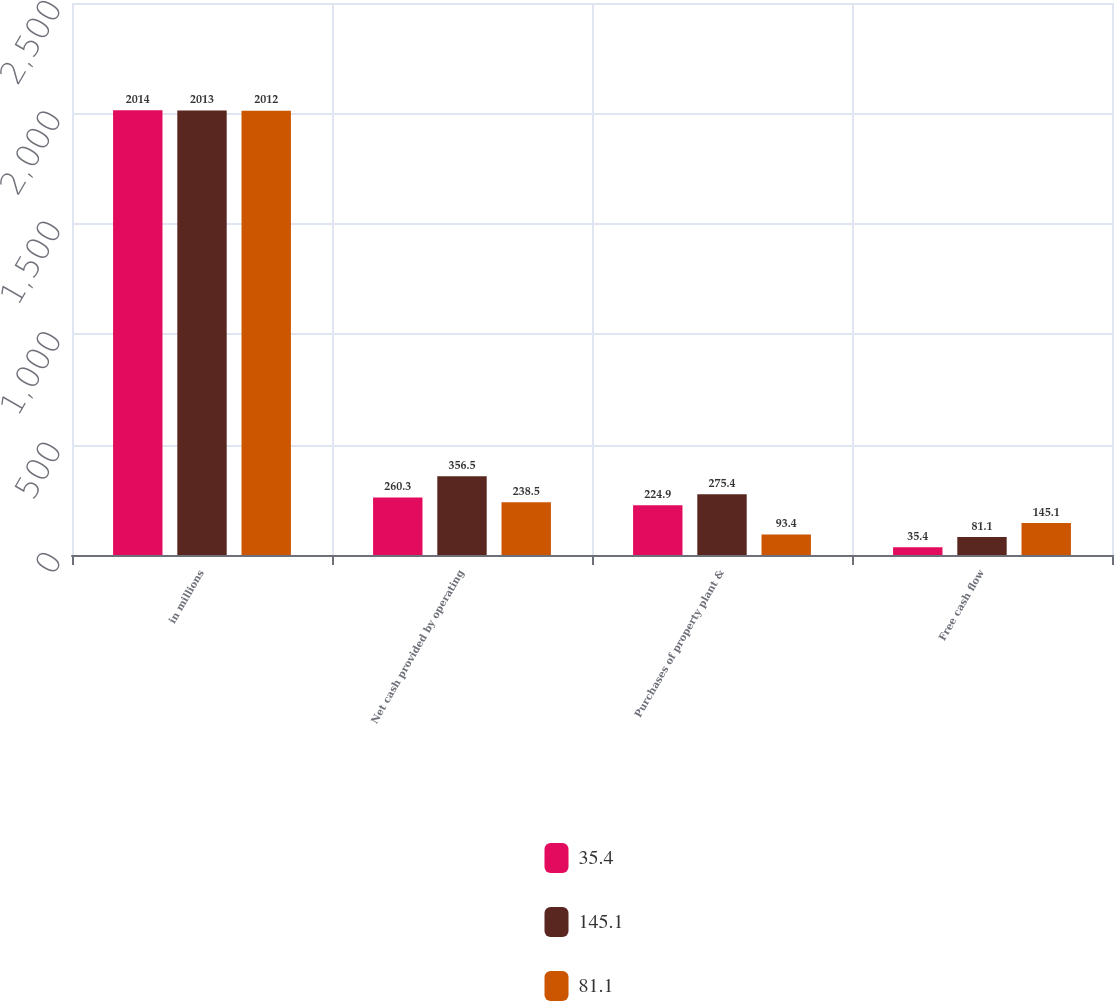Convert chart to OTSL. <chart><loc_0><loc_0><loc_500><loc_500><stacked_bar_chart><ecel><fcel>in millions<fcel>Net cash provided by operating<fcel>Purchases of property plant &<fcel>Free cash flow<nl><fcel>35.4<fcel>2014<fcel>260.3<fcel>224.9<fcel>35.4<nl><fcel>145.1<fcel>2013<fcel>356.5<fcel>275.4<fcel>81.1<nl><fcel>81.1<fcel>2012<fcel>238.5<fcel>93.4<fcel>145.1<nl></chart> 